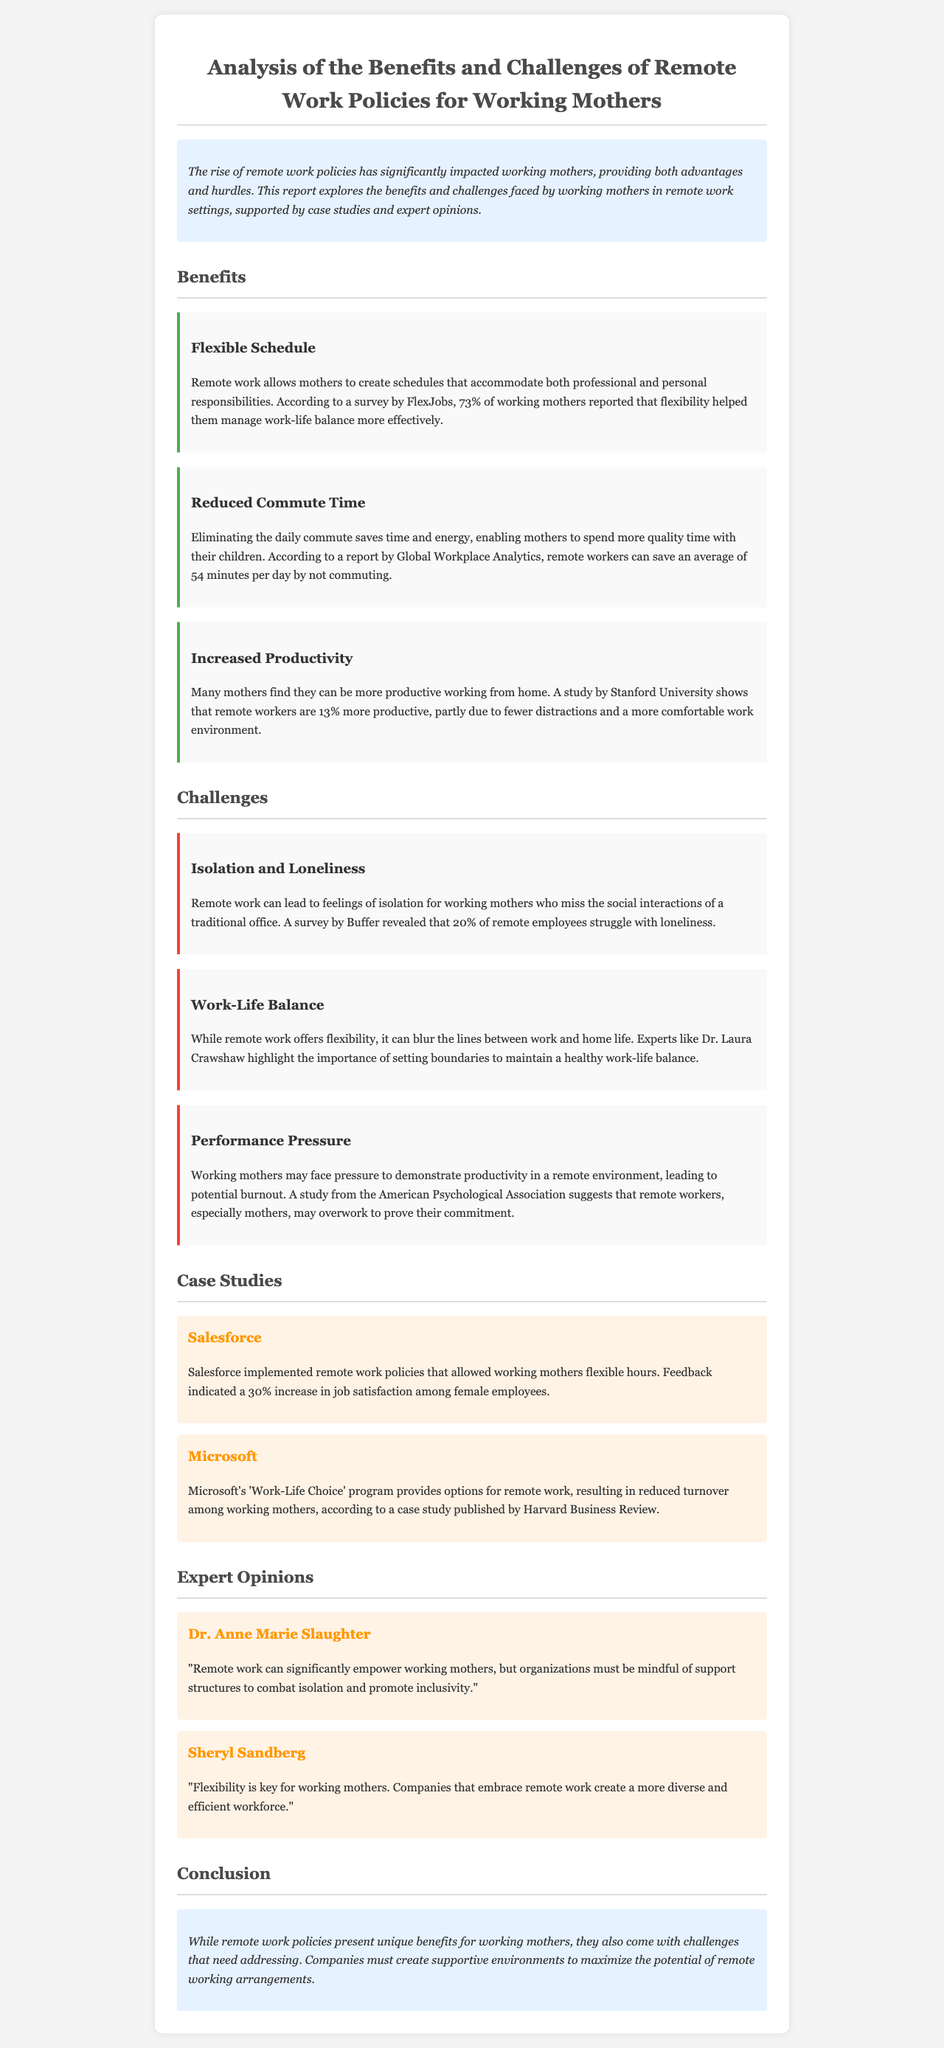What percentage of working mothers reported that flexibility helped them manage work-life balance? According to a survey by FlexJobs, 73% of working mothers reported that flexibility helped them manage work-life balance more effectively.
Answer: 73% What is one major benefit of remote work highlighted in the report? The benefits section outlines multiple advantages, including "Flexible Schedule" as a significant benefit for working mothers.
Answer: Flexible Schedule Which company implemented remote work policies that led to a 30% increase in job satisfaction among female employees? The case study on Salesforce mentions a 30% increase in job satisfaction due to implemented remote work policies.
Answer: Salesforce What challenge do 20% of remote employees struggle with, as mentioned in the report? A survey by Buffer revealed that 20% of remote employees struggle with loneliness, indicating it's a notable challenge for working mothers.
Answer: Loneliness What recommendation does Dr. Laura Crawshaw provide regarding remote work? The report highlights that Dr. Laura Crawshaw emphasizes the importance of setting boundaries to maintain a healthy work-life balance.
Answer: Setting boundaries How much more productive are remote workers, according to the study by Stanford University? A study by Stanford University shows that remote workers are 13% more productive, suggesting a clear advantage in productivity for those working remotely.
Answer: 13% What is one quoted opinion from Sheryl Sandberg regarding remote work for working mothers? Sheryl Sandberg mentions that "Flexibility is key for working mothers," summarizing her views on the importance of flexible working arrangements.
Answer: Flexibility is key for working mothers What is the overall conclusion regarding remote work policies for working mothers? The conclusion states that while remote work policies present unique benefits for working mothers, they also come with challenges that need addressing.
Answer: Unique benefits and challenges 